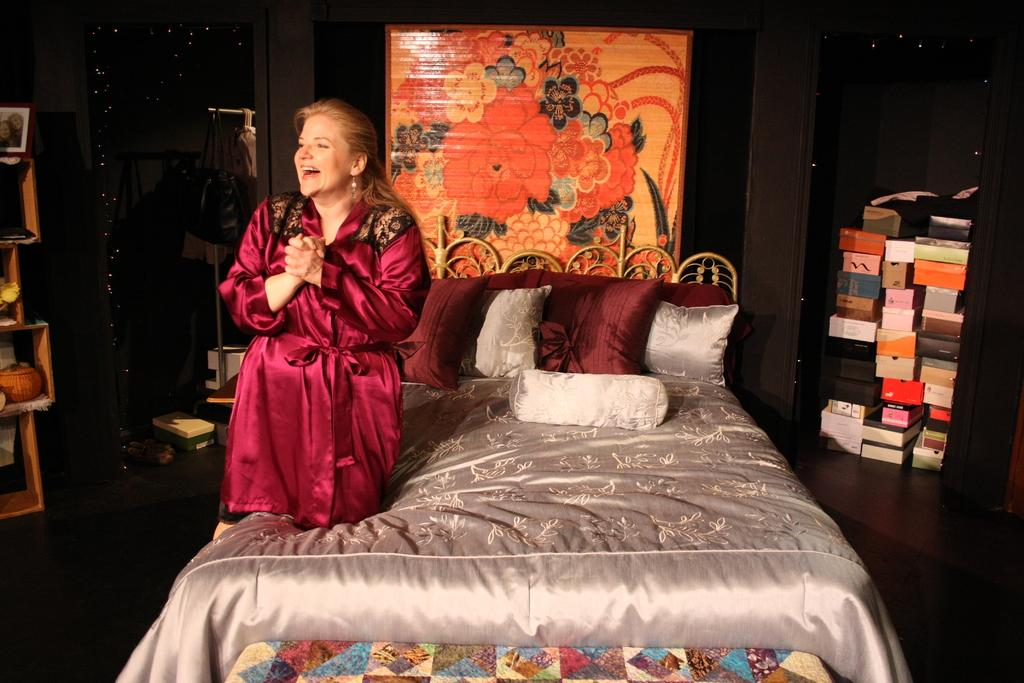Who is present in the image? There is a woman in the image. What is the woman doing in the image? The woman is on a bed. What can be seen on the bed besides the woman? There are pillows on the bed. What is located on the right side of the image? There are boxes on the right side of the image. What is behind the bed in the image? There is a mat behind the bed. What type of rings can be seen on the woman's fingers in the image? There are no rings visible on the woman's fingers in the image. Can you describe the sea visible in the background of the image? There is no sea present in the image; it features a woman on a bed with pillows, boxes, and a mat. 